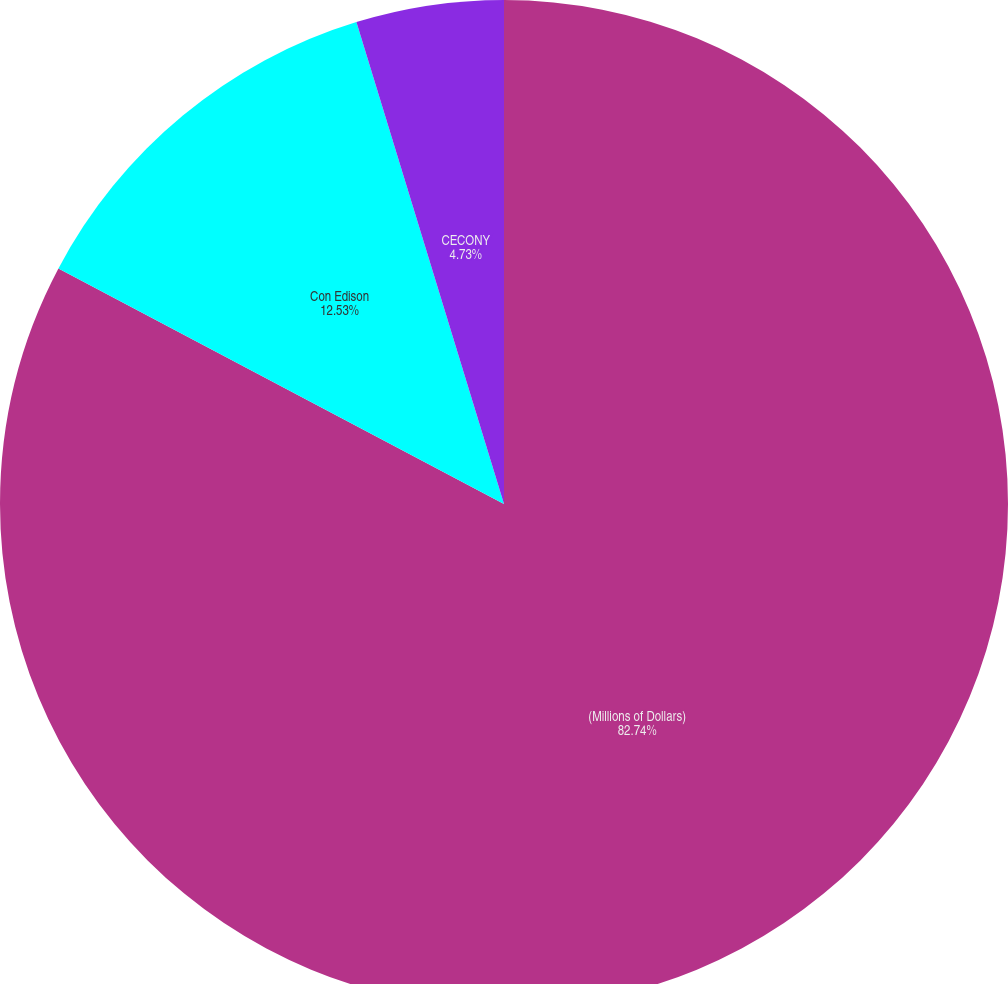Convert chart. <chart><loc_0><loc_0><loc_500><loc_500><pie_chart><fcel>(Millions of Dollars)<fcel>Con Edison<fcel>CECONY<nl><fcel>82.74%<fcel>12.53%<fcel>4.73%<nl></chart> 